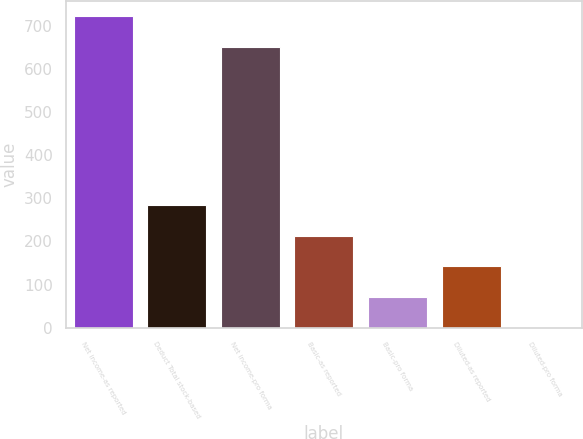Convert chart to OTSL. <chart><loc_0><loc_0><loc_500><loc_500><bar_chart><fcel>Net income-as reported<fcel>Deduct Total stock-based<fcel>Net income-pro forma<fcel>Basic-as reported<fcel>Basic-pro forma<fcel>Diluted-as reported<fcel>Diluted-pro forma<nl><fcel>722.57<fcel>283.59<fcel>652<fcel>213.02<fcel>71.88<fcel>142.45<fcel>1.31<nl></chart> 